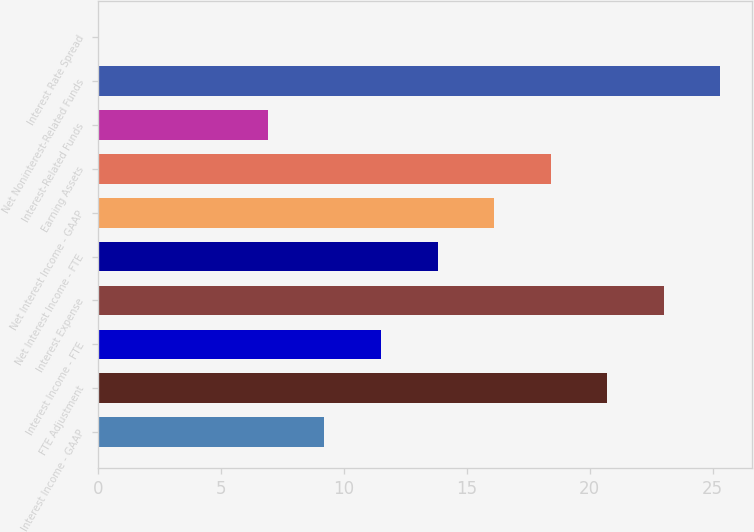Convert chart. <chart><loc_0><loc_0><loc_500><loc_500><bar_chart><fcel>Interest Income - GAAP<fcel>FTE Adjustment<fcel>Interest Income - FTE<fcel>Interest Expense<fcel>Net Interest Income - FTE<fcel>Net Interest Income - GAAP<fcel>Earning Assets<fcel>Interest-Related Funds<fcel>Net Noninterest-Related Funds<fcel>Interest Rate Spread<nl><fcel>9.21<fcel>20.71<fcel>11.51<fcel>23.01<fcel>13.81<fcel>16.11<fcel>18.41<fcel>6.91<fcel>25.31<fcel>0.01<nl></chart> 